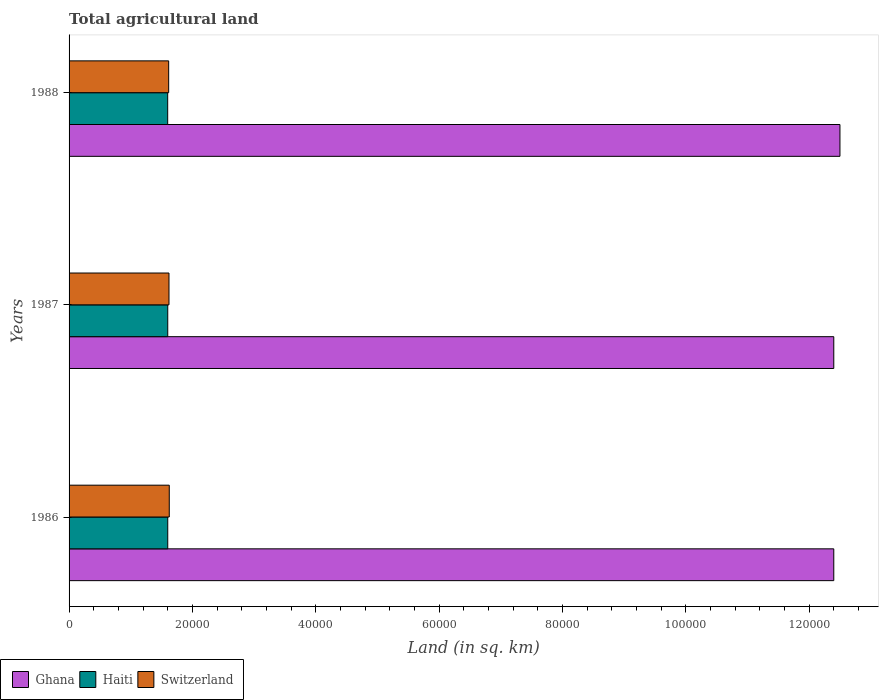Are the number of bars on each tick of the Y-axis equal?
Your answer should be very brief. Yes. How many bars are there on the 1st tick from the bottom?
Give a very brief answer. 3. What is the label of the 3rd group of bars from the top?
Ensure brevity in your answer.  1986. In how many cases, is the number of bars for a given year not equal to the number of legend labels?
Ensure brevity in your answer.  0. What is the total agricultural land in Ghana in 1987?
Your answer should be compact. 1.24e+05. Across all years, what is the maximum total agricultural land in Haiti?
Offer a very short reply. 1.60e+04. Across all years, what is the minimum total agricultural land in Haiti?
Your answer should be very brief. 1.60e+04. In which year was the total agricultural land in Haiti maximum?
Your response must be concise. 1986. In which year was the total agricultural land in Switzerland minimum?
Make the answer very short. 1988. What is the total total agricultural land in Ghana in the graph?
Your response must be concise. 3.73e+05. What is the difference between the total agricultural land in Haiti in 1988 and the total agricultural land in Switzerland in 1986?
Make the answer very short. -258. What is the average total agricultural land in Switzerland per year?
Your answer should be very brief. 1.62e+04. In the year 1988, what is the difference between the total agricultural land in Ghana and total agricultural land in Haiti?
Offer a very short reply. 1.09e+05. What is the ratio of the total agricultural land in Ghana in 1987 to that in 1988?
Your answer should be very brief. 0.99. What is the difference between the highest and the second highest total agricultural land in Haiti?
Make the answer very short. 0. What is the difference between the highest and the lowest total agricultural land in Haiti?
Keep it short and to the point. 10. In how many years, is the total agricultural land in Switzerland greater than the average total agricultural land in Switzerland taken over all years?
Provide a succinct answer. 2. Is the sum of the total agricultural land in Switzerland in 1986 and 1987 greater than the maximum total agricultural land in Ghana across all years?
Your answer should be compact. No. What does the 1st bar from the top in 1988 represents?
Provide a succinct answer. Switzerland. What does the 3rd bar from the bottom in 1988 represents?
Your answer should be compact. Switzerland. How many bars are there?
Offer a terse response. 9. Are all the bars in the graph horizontal?
Provide a succinct answer. Yes. Are the values on the major ticks of X-axis written in scientific E-notation?
Make the answer very short. No. Does the graph contain any zero values?
Ensure brevity in your answer.  No. Where does the legend appear in the graph?
Keep it short and to the point. Bottom left. How many legend labels are there?
Provide a succinct answer. 3. How are the legend labels stacked?
Offer a very short reply. Horizontal. What is the title of the graph?
Your answer should be very brief. Total agricultural land. Does "Guinea-Bissau" appear as one of the legend labels in the graph?
Your answer should be very brief. No. What is the label or title of the X-axis?
Your answer should be very brief. Land (in sq. km). What is the Land (in sq. km) in Ghana in 1986?
Your answer should be compact. 1.24e+05. What is the Land (in sq. km) in Haiti in 1986?
Provide a short and direct response. 1.60e+04. What is the Land (in sq. km) in Switzerland in 1986?
Offer a terse response. 1.62e+04. What is the Land (in sq. km) in Ghana in 1987?
Ensure brevity in your answer.  1.24e+05. What is the Land (in sq. km) in Haiti in 1987?
Your answer should be compact. 1.60e+04. What is the Land (in sq. km) of Switzerland in 1987?
Your response must be concise. 1.62e+04. What is the Land (in sq. km) in Ghana in 1988?
Provide a short and direct response. 1.25e+05. What is the Land (in sq. km) of Haiti in 1988?
Offer a terse response. 1.60e+04. What is the Land (in sq. km) of Switzerland in 1988?
Your answer should be compact. 1.62e+04. Across all years, what is the maximum Land (in sq. km) in Ghana?
Ensure brevity in your answer.  1.25e+05. Across all years, what is the maximum Land (in sq. km) in Haiti?
Ensure brevity in your answer.  1.60e+04. Across all years, what is the maximum Land (in sq. km) in Switzerland?
Provide a short and direct response. 1.62e+04. Across all years, what is the minimum Land (in sq. km) of Ghana?
Offer a terse response. 1.24e+05. Across all years, what is the minimum Land (in sq. km) of Haiti?
Give a very brief answer. 1.60e+04. Across all years, what is the minimum Land (in sq. km) of Switzerland?
Your answer should be very brief. 1.62e+04. What is the total Land (in sq. km) in Ghana in the graph?
Your answer should be compact. 3.73e+05. What is the total Land (in sq. km) in Haiti in the graph?
Offer a terse response. 4.80e+04. What is the total Land (in sq. km) in Switzerland in the graph?
Provide a short and direct response. 4.86e+04. What is the difference between the Land (in sq. km) in Haiti in 1986 and that in 1987?
Your response must be concise. 0. What is the difference between the Land (in sq. km) of Ghana in 1986 and that in 1988?
Make the answer very short. -1000. What is the difference between the Land (in sq. km) of Switzerland in 1986 and that in 1988?
Your response must be concise. 97. What is the difference between the Land (in sq. km) of Ghana in 1987 and that in 1988?
Provide a short and direct response. -1000. What is the difference between the Land (in sq. km) in Ghana in 1986 and the Land (in sq. km) in Haiti in 1987?
Give a very brief answer. 1.08e+05. What is the difference between the Land (in sq. km) of Ghana in 1986 and the Land (in sq. km) of Switzerland in 1987?
Offer a very short reply. 1.08e+05. What is the difference between the Land (in sq. km) in Haiti in 1986 and the Land (in sq. km) in Switzerland in 1987?
Provide a short and direct response. -200. What is the difference between the Land (in sq. km) in Ghana in 1986 and the Land (in sq. km) in Haiti in 1988?
Your answer should be compact. 1.08e+05. What is the difference between the Land (in sq. km) in Ghana in 1986 and the Land (in sq. km) in Switzerland in 1988?
Offer a terse response. 1.08e+05. What is the difference between the Land (in sq. km) in Haiti in 1986 and the Land (in sq. km) in Switzerland in 1988?
Your answer should be very brief. -151. What is the difference between the Land (in sq. km) of Ghana in 1987 and the Land (in sq. km) of Haiti in 1988?
Your answer should be compact. 1.08e+05. What is the difference between the Land (in sq. km) in Ghana in 1987 and the Land (in sq. km) in Switzerland in 1988?
Give a very brief answer. 1.08e+05. What is the difference between the Land (in sq. km) in Haiti in 1987 and the Land (in sq. km) in Switzerland in 1988?
Give a very brief answer. -151. What is the average Land (in sq. km) in Ghana per year?
Provide a succinct answer. 1.24e+05. What is the average Land (in sq. km) of Haiti per year?
Ensure brevity in your answer.  1.60e+04. What is the average Land (in sq. km) of Switzerland per year?
Give a very brief answer. 1.62e+04. In the year 1986, what is the difference between the Land (in sq. km) of Ghana and Land (in sq. km) of Haiti?
Ensure brevity in your answer.  1.08e+05. In the year 1986, what is the difference between the Land (in sq. km) of Ghana and Land (in sq. km) of Switzerland?
Offer a very short reply. 1.08e+05. In the year 1986, what is the difference between the Land (in sq. km) of Haiti and Land (in sq. km) of Switzerland?
Keep it short and to the point. -248. In the year 1987, what is the difference between the Land (in sq. km) in Ghana and Land (in sq. km) in Haiti?
Keep it short and to the point. 1.08e+05. In the year 1987, what is the difference between the Land (in sq. km) in Ghana and Land (in sq. km) in Switzerland?
Your answer should be very brief. 1.08e+05. In the year 1987, what is the difference between the Land (in sq. km) of Haiti and Land (in sq. km) of Switzerland?
Offer a very short reply. -200. In the year 1988, what is the difference between the Land (in sq. km) of Ghana and Land (in sq. km) of Haiti?
Keep it short and to the point. 1.09e+05. In the year 1988, what is the difference between the Land (in sq. km) in Ghana and Land (in sq. km) in Switzerland?
Keep it short and to the point. 1.09e+05. In the year 1988, what is the difference between the Land (in sq. km) in Haiti and Land (in sq. km) in Switzerland?
Your response must be concise. -161. What is the ratio of the Land (in sq. km) in Ghana in 1986 to that in 1987?
Offer a terse response. 1. What is the ratio of the Land (in sq. km) in Haiti in 1986 to that in 1987?
Give a very brief answer. 1. What is the ratio of the Land (in sq. km) of Switzerland in 1986 to that in 1987?
Offer a terse response. 1. What is the ratio of the Land (in sq. km) of Haiti in 1986 to that in 1988?
Give a very brief answer. 1. What is the ratio of the Land (in sq. km) of Ghana in 1987 to that in 1988?
Offer a terse response. 0.99. What is the ratio of the Land (in sq. km) of Switzerland in 1987 to that in 1988?
Offer a very short reply. 1. What is the difference between the highest and the second highest Land (in sq. km) in Ghana?
Your answer should be very brief. 1000. What is the difference between the highest and the second highest Land (in sq. km) of Haiti?
Provide a succinct answer. 0. What is the difference between the highest and the second highest Land (in sq. km) in Switzerland?
Offer a terse response. 48. What is the difference between the highest and the lowest Land (in sq. km) of Haiti?
Your answer should be compact. 10. What is the difference between the highest and the lowest Land (in sq. km) of Switzerland?
Make the answer very short. 97. 